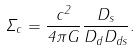<formula> <loc_0><loc_0><loc_500><loc_500>\Sigma _ { c } = \frac { c ^ { 2 } } { 4 \pi G } \frac { D _ { s } } { D _ { d } D _ { d s } } .</formula> 